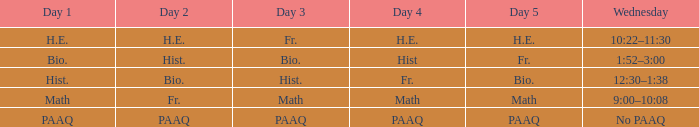What is the day 3 when day 4 is fr.? Hist. 